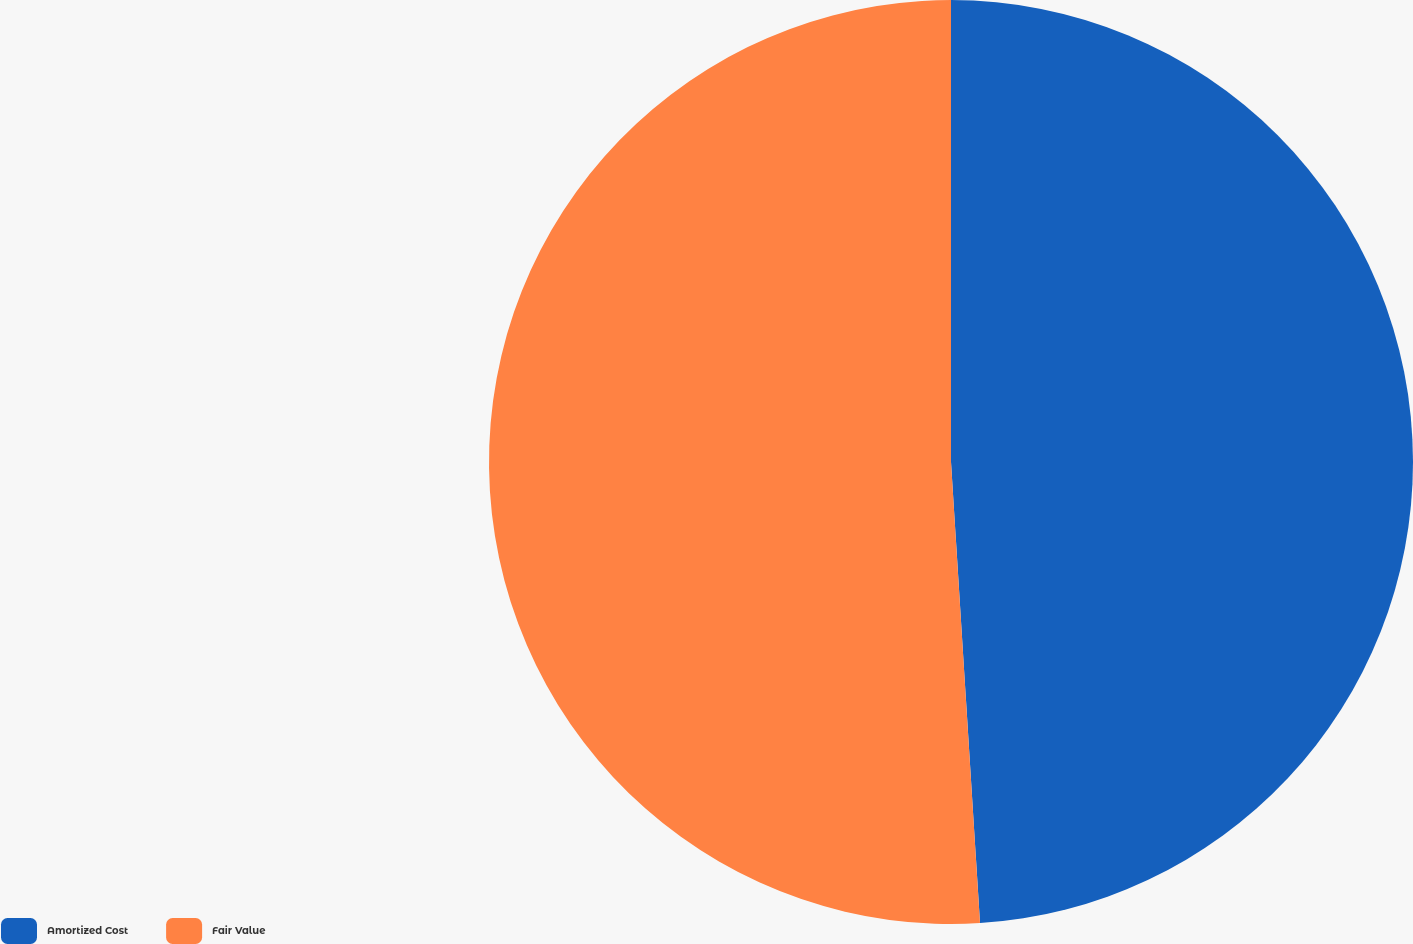<chart> <loc_0><loc_0><loc_500><loc_500><pie_chart><fcel>Amortized Cost<fcel>Fair Value<nl><fcel>49.0%<fcel>51.0%<nl></chart> 